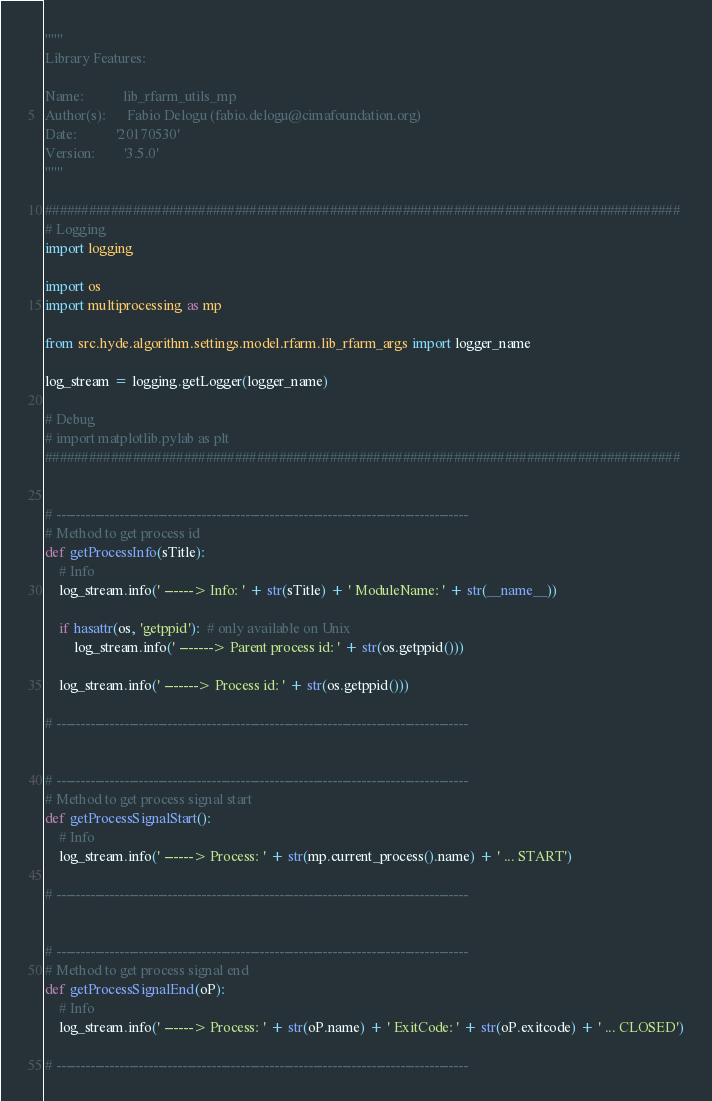Convert code to text. <code><loc_0><loc_0><loc_500><loc_500><_Python_>"""
Library Features:

Name:           lib_rfarm_utils_mp
Author(s):      Fabio Delogu (fabio.delogu@cimafoundation.org)
Date:           '20170530'
Version:        '3.5.0'
"""

#######################################################################################
# Logging
import logging

import os
import multiprocessing as mp

from src.hyde.algorithm.settings.model.rfarm.lib_rfarm_args import logger_name

log_stream = logging.getLogger(logger_name)

# Debug
# import matplotlib.pylab as plt
#######################################################################################


# -------------------------------------------------------------------------------------
# Method to get process id
def getProcessInfo(sTitle):
    # Info
    log_stream.info(' ------> Info: ' + str(sTitle) + ' ModuleName: ' + str(__name__))

    if hasattr(os, 'getppid'):  # only available on Unix
        log_stream.info(' -------> Parent process id: ' + str(os.getppid()))

    log_stream.info(' -------> Process id: ' + str(os.getppid()))

# -------------------------------------------------------------------------------------


# -------------------------------------------------------------------------------------
# Method to get process signal start
def getProcessSignalStart():
    # Info
    log_stream.info(' ------> Process: ' + str(mp.current_process().name) + ' ... START')

# -------------------------------------------------------------------------------------


# -------------------------------------------------------------------------------------
# Method to get process signal end
def getProcessSignalEnd(oP):
    # Info
    log_stream.info(' ------> Process: ' + str(oP.name) + ' ExitCode: ' + str(oP.exitcode) + ' ... CLOSED')

# -------------------------------------------------------------------------------------
</code> 